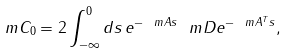Convert formula to latex. <formula><loc_0><loc_0><loc_500><loc_500>\ m C _ { 0 } = 2 \int _ { - \infty } ^ { 0 } d s \, e ^ { - \ m A s } \ m D e ^ { - \ m A ^ { T } s } ,</formula> 